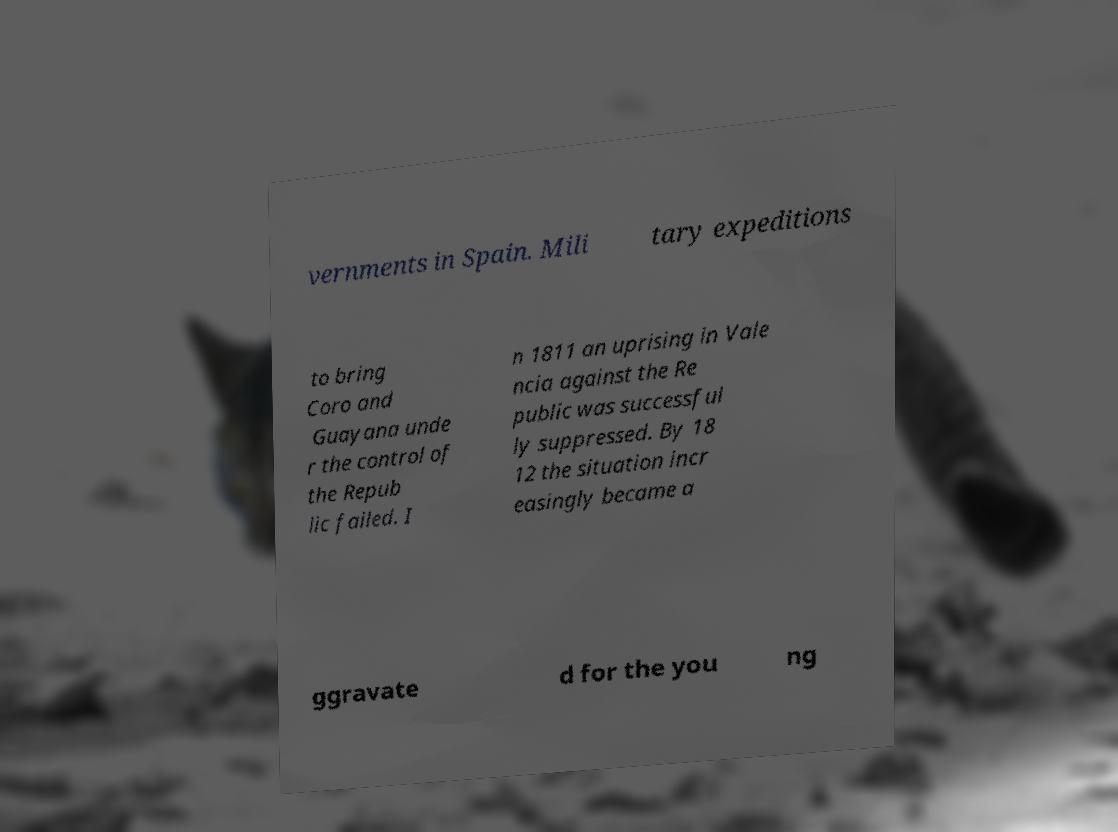Could you extract and type out the text from this image? vernments in Spain. Mili tary expeditions to bring Coro and Guayana unde r the control of the Repub lic failed. I n 1811 an uprising in Vale ncia against the Re public was successful ly suppressed. By 18 12 the situation incr easingly became a ggravate d for the you ng 